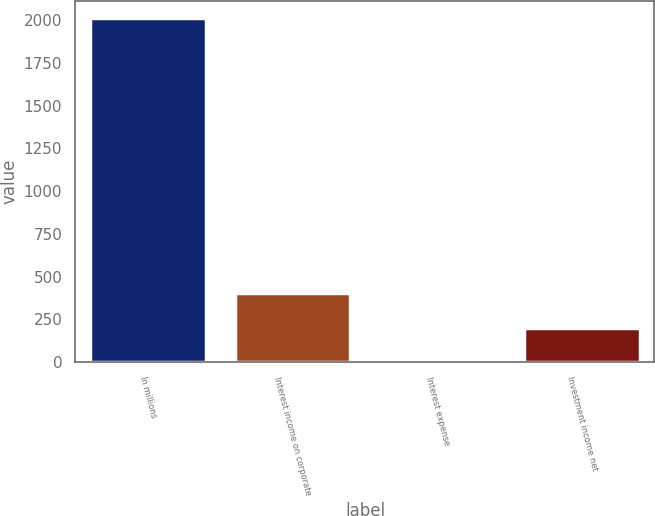Convert chart. <chart><loc_0><loc_0><loc_500><loc_500><bar_chart><fcel>In millions<fcel>Interest income on corporate<fcel>Interest expense<fcel>Investment income net<nl><fcel>2013<fcel>402.68<fcel>0.1<fcel>201.39<nl></chart> 